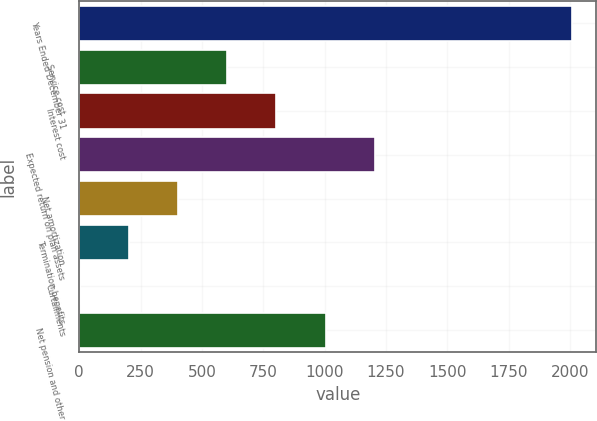Convert chart. <chart><loc_0><loc_0><loc_500><loc_500><bar_chart><fcel>Years Ended December 31<fcel>Service cost<fcel>Interest cost<fcel>Expected return on plan assets<fcel>Net amortization<fcel>Termination benefits<fcel>Curtailments<fcel>Net pension and other<nl><fcel>2007<fcel>602.87<fcel>803.46<fcel>1204.64<fcel>402.28<fcel>201.69<fcel>1.1<fcel>1004.05<nl></chart> 